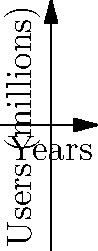The graph shows the growth of three social media platforms over 4 years. Platform A is represented by $f(x) = 0.5x^3 - 2x^2 + 2.5x + 1$, Platform B by $g(x) = -0.25x^3 + 1.5x^2 - 0.5x + 2$, and Platform C by $h(x) = 0.1x^3 - 0.5x^2 + 2x + 0.5$, where $x$ represents years and $f(x)$, $g(x)$, and $h(x)$ represent millions of users. At which year does Platform A overtake Platform B in terms of user count? To find when Platform A overtakes Platform B, we need to solve the equation $f(x) = g(x)$:

1) Set up the equation:
   $0.5x^3 - 2x^2 + 2.5x + 1 = -0.25x^3 + 1.5x^2 - 0.5x + 2$

2) Rearrange terms:
   $0.75x^3 - 3.5x^2 + 3x - 1 = 0$

3) This is a cubic equation. We can solve it graphically or using numerical methods. From the graph, we can see the intersection occurs between x = 2 and x = 3.

4) Using a numerical solver or calculator, we find that the equation has one real root at approximately x = 2.4.

5) This means Platform A overtakes Platform B after 2.4 years.

6) Since we're dealing with whole years in the context of the question, we round up to 3 years.
Answer: 3 years 